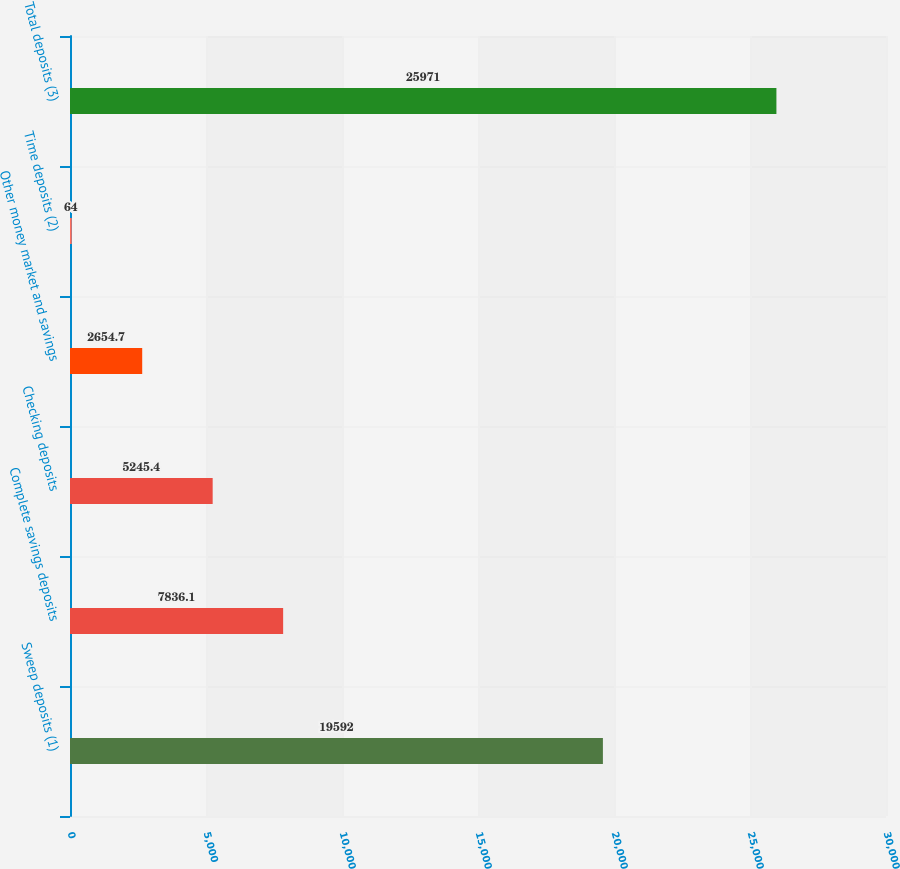Convert chart to OTSL. <chart><loc_0><loc_0><loc_500><loc_500><bar_chart><fcel>Sweep deposits (1)<fcel>Complete savings deposits<fcel>Checking deposits<fcel>Other money market and savings<fcel>Time deposits (2)<fcel>Total deposits (3)<nl><fcel>19592<fcel>7836.1<fcel>5245.4<fcel>2654.7<fcel>64<fcel>25971<nl></chart> 